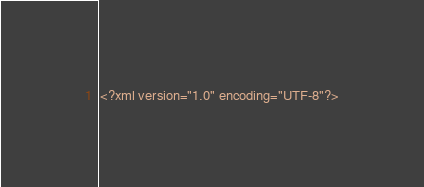<code> <loc_0><loc_0><loc_500><loc_500><_XML_><?xml version="1.0" encoding="UTF-8"?></code> 